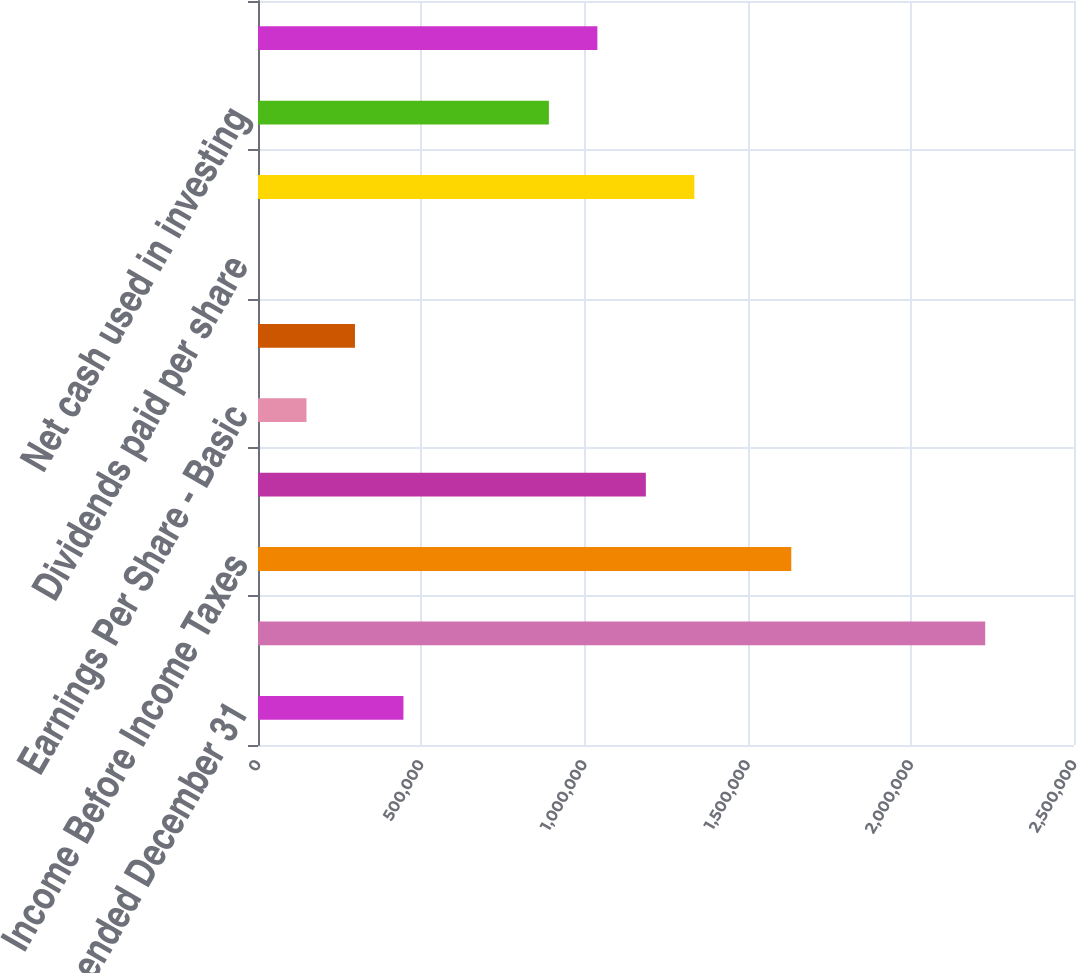Convert chart to OTSL. <chart><loc_0><loc_0><loc_500><loc_500><bar_chart><fcel>Years ended December 31<fcel>Revenues<fcel>Income Before Income Taxes<fcel>Net Income<fcel>Earnings Per Share - Basic<fcel>Earnings Per Share - Diluted<fcel>Dividends paid per share<fcel>Net cash provided by operating<fcel>Net cash used in investing<fcel>Net cash used in financing<nl><fcel>445592<fcel>2.22796e+06<fcel>1.63384e+06<fcel>1.18824e+06<fcel>148531<fcel>297061<fcel>0.42<fcel>1.33677e+06<fcel>891183<fcel>1.03971e+06<nl></chart> 